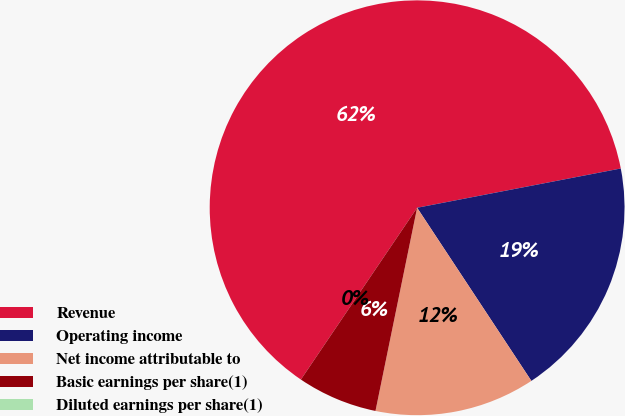Convert chart. <chart><loc_0><loc_0><loc_500><loc_500><pie_chart><fcel>Revenue<fcel>Operating income<fcel>Net income attributable to<fcel>Basic earnings per share(1)<fcel>Diluted earnings per share(1)<nl><fcel>62.5%<fcel>18.75%<fcel>12.5%<fcel>6.25%<fcel>0.0%<nl></chart> 